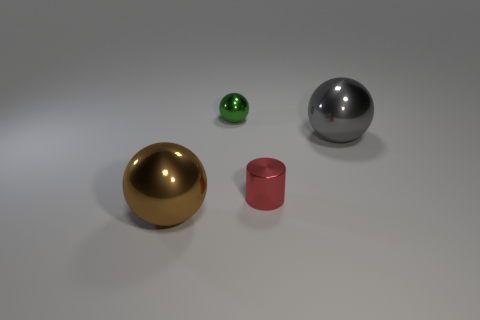How many objects are there?
Give a very brief answer. 4. There is a tiny object in front of the gray metallic thing; what is its color?
Offer a very short reply. Red. What color is the metal object that is behind the ball to the right of the tiny shiny cylinder?
Your answer should be very brief. Green. What is the color of the shiny thing that is the same size as the red cylinder?
Offer a very short reply. Green. What number of metallic objects are left of the big gray object and behind the tiny red metallic object?
Keep it short and to the point. 1. There is a sphere that is on the right side of the brown shiny object and left of the big gray metal object; what material is it?
Offer a terse response. Metal. Is the number of green shiny things right of the small red object less than the number of large brown balls behind the brown metal object?
Give a very brief answer. No. What size is the brown ball that is made of the same material as the big gray thing?
Keep it short and to the point. Large. Are there any other things that have the same color as the tiny cylinder?
Make the answer very short. No. Do the small red thing and the small ball that is behind the brown thing have the same material?
Make the answer very short. Yes. 